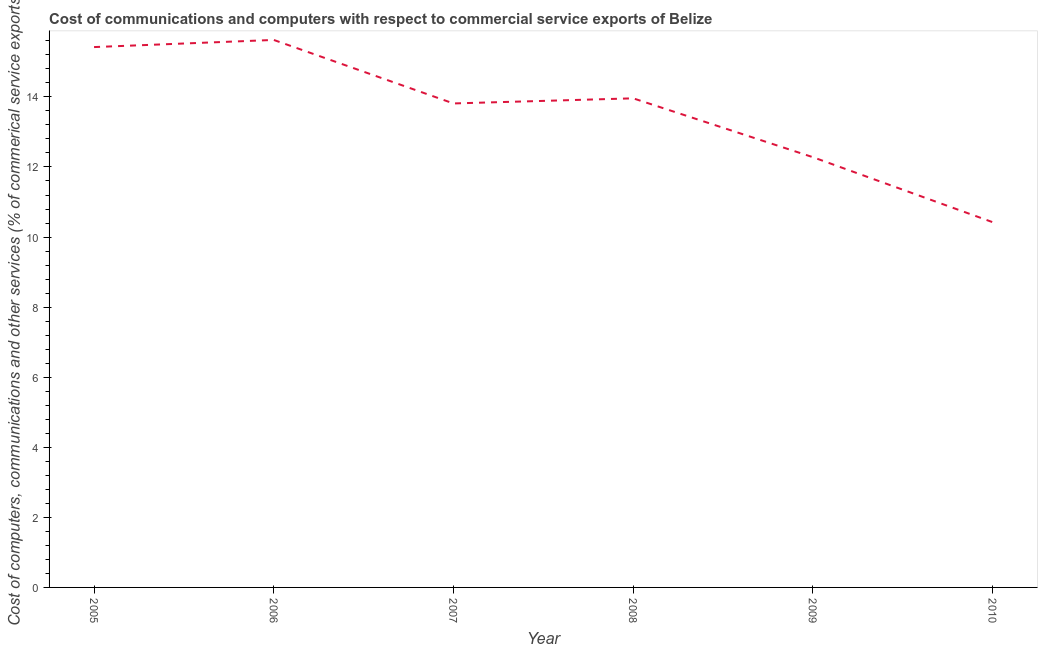What is the cost of communications in 2009?
Make the answer very short. 12.28. Across all years, what is the maximum  computer and other services?
Offer a terse response. 15.63. Across all years, what is the minimum  computer and other services?
Offer a terse response. 10.43. What is the sum of the cost of communications?
Your response must be concise. 81.52. What is the difference between the  computer and other services in 2007 and 2008?
Make the answer very short. -0.15. What is the average  computer and other services per year?
Make the answer very short. 13.59. What is the median  computer and other services?
Offer a terse response. 13.89. Do a majority of the years between 2010 and 2009 (inclusive) have cost of communications greater than 5.6 %?
Provide a short and direct response. No. What is the ratio of the  computer and other services in 2006 to that in 2009?
Make the answer very short. 1.27. What is the difference between the highest and the second highest  computer and other services?
Give a very brief answer. 0.2. Is the sum of the  computer and other services in 2008 and 2010 greater than the maximum  computer and other services across all years?
Ensure brevity in your answer.  Yes. What is the difference between the highest and the lowest  computer and other services?
Offer a terse response. 5.2. In how many years, is the  computer and other services greater than the average  computer and other services taken over all years?
Keep it short and to the point. 4. How many lines are there?
Make the answer very short. 1. What is the difference between two consecutive major ticks on the Y-axis?
Your answer should be compact. 2. Does the graph contain grids?
Make the answer very short. No. What is the title of the graph?
Make the answer very short. Cost of communications and computers with respect to commercial service exports of Belize. What is the label or title of the Y-axis?
Offer a terse response. Cost of computers, communications and other services (% of commerical service exports). What is the Cost of computers, communications and other services (% of commerical service exports) of 2005?
Make the answer very short. 15.42. What is the Cost of computers, communications and other services (% of commerical service exports) of 2006?
Provide a short and direct response. 15.63. What is the Cost of computers, communications and other services (% of commerical service exports) in 2007?
Offer a terse response. 13.81. What is the Cost of computers, communications and other services (% of commerical service exports) of 2008?
Make the answer very short. 13.96. What is the Cost of computers, communications and other services (% of commerical service exports) of 2009?
Offer a terse response. 12.28. What is the Cost of computers, communications and other services (% of commerical service exports) of 2010?
Your response must be concise. 10.43. What is the difference between the Cost of computers, communications and other services (% of commerical service exports) in 2005 and 2006?
Your answer should be very brief. -0.2. What is the difference between the Cost of computers, communications and other services (% of commerical service exports) in 2005 and 2007?
Make the answer very short. 1.61. What is the difference between the Cost of computers, communications and other services (% of commerical service exports) in 2005 and 2008?
Provide a succinct answer. 1.46. What is the difference between the Cost of computers, communications and other services (% of commerical service exports) in 2005 and 2009?
Offer a very short reply. 3.14. What is the difference between the Cost of computers, communications and other services (% of commerical service exports) in 2005 and 2010?
Your response must be concise. 5. What is the difference between the Cost of computers, communications and other services (% of commerical service exports) in 2006 and 2007?
Keep it short and to the point. 1.81. What is the difference between the Cost of computers, communications and other services (% of commerical service exports) in 2006 and 2008?
Give a very brief answer. 1.67. What is the difference between the Cost of computers, communications and other services (% of commerical service exports) in 2006 and 2009?
Your response must be concise. 3.35. What is the difference between the Cost of computers, communications and other services (% of commerical service exports) in 2006 and 2010?
Make the answer very short. 5.2. What is the difference between the Cost of computers, communications and other services (% of commerical service exports) in 2007 and 2008?
Your response must be concise. -0.15. What is the difference between the Cost of computers, communications and other services (% of commerical service exports) in 2007 and 2009?
Provide a succinct answer. 1.53. What is the difference between the Cost of computers, communications and other services (% of commerical service exports) in 2007 and 2010?
Your answer should be compact. 3.39. What is the difference between the Cost of computers, communications and other services (% of commerical service exports) in 2008 and 2009?
Provide a short and direct response. 1.68. What is the difference between the Cost of computers, communications and other services (% of commerical service exports) in 2008 and 2010?
Give a very brief answer. 3.53. What is the difference between the Cost of computers, communications and other services (% of commerical service exports) in 2009 and 2010?
Ensure brevity in your answer.  1.85. What is the ratio of the Cost of computers, communications and other services (% of commerical service exports) in 2005 to that in 2006?
Ensure brevity in your answer.  0.99. What is the ratio of the Cost of computers, communications and other services (% of commerical service exports) in 2005 to that in 2007?
Your answer should be very brief. 1.12. What is the ratio of the Cost of computers, communications and other services (% of commerical service exports) in 2005 to that in 2008?
Make the answer very short. 1.1. What is the ratio of the Cost of computers, communications and other services (% of commerical service exports) in 2005 to that in 2009?
Keep it short and to the point. 1.26. What is the ratio of the Cost of computers, communications and other services (% of commerical service exports) in 2005 to that in 2010?
Offer a terse response. 1.48. What is the ratio of the Cost of computers, communications and other services (% of commerical service exports) in 2006 to that in 2007?
Make the answer very short. 1.13. What is the ratio of the Cost of computers, communications and other services (% of commerical service exports) in 2006 to that in 2008?
Your answer should be compact. 1.12. What is the ratio of the Cost of computers, communications and other services (% of commerical service exports) in 2006 to that in 2009?
Ensure brevity in your answer.  1.27. What is the ratio of the Cost of computers, communications and other services (% of commerical service exports) in 2006 to that in 2010?
Provide a short and direct response. 1.5. What is the ratio of the Cost of computers, communications and other services (% of commerical service exports) in 2007 to that in 2009?
Offer a very short reply. 1.12. What is the ratio of the Cost of computers, communications and other services (% of commerical service exports) in 2007 to that in 2010?
Ensure brevity in your answer.  1.32. What is the ratio of the Cost of computers, communications and other services (% of commerical service exports) in 2008 to that in 2009?
Keep it short and to the point. 1.14. What is the ratio of the Cost of computers, communications and other services (% of commerical service exports) in 2008 to that in 2010?
Keep it short and to the point. 1.34. What is the ratio of the Cost of computers, communications and other services (% of commerical service exports) in 2009 to that in 2010?
Provide a succinct answer. 1.18. 